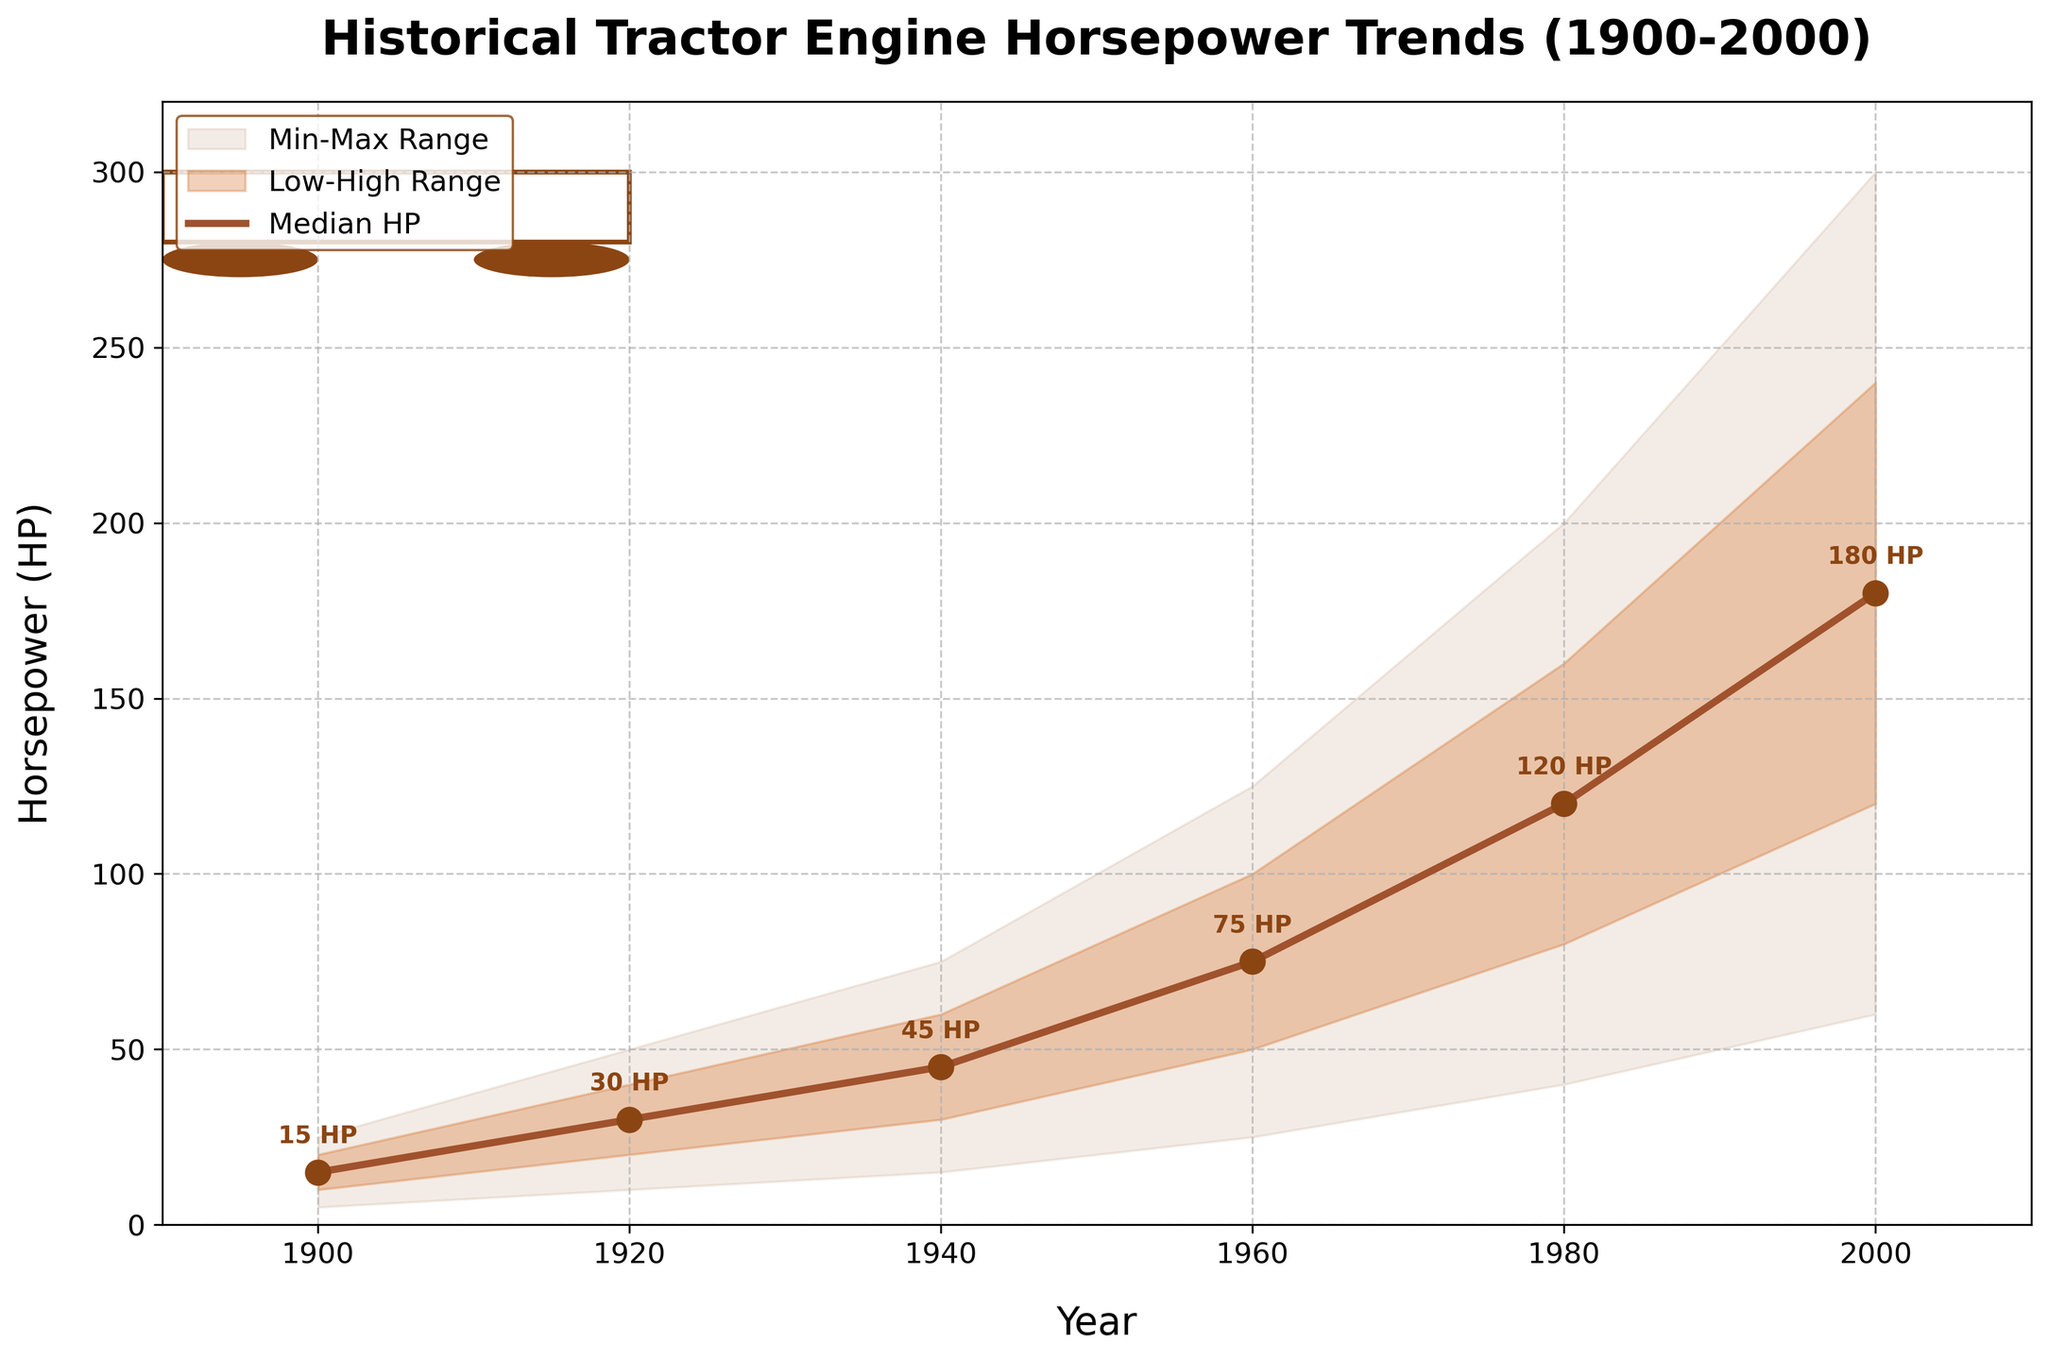What is the title of the figure? The title of the figure is typically found at the top and provides an overview of what the figure represents. In this case, the title reads "Historical Tractor Engine Horsepower Trends (1900-2000)."
Answer: Historical Tractor Engine Horsepower Trends (1900-2000) What are the units used on the y-axis? The y-axis represents the measure of tractor engine horsepower, as indicated by the "Horsepower (HP)" label on the vertical axis.
Answer: Horsepower (HP) How many years are displayed on the x-axis? To determine the number of years displayed, count each individual tick on the x-axis. The data represents the years 1900, 1920, 1940, 1960, 1980, and 2000.
Answer: 6 What is the range of horsepower in the year 2000? The range of horsepower for any given year can be found by looking at the Min HP and Max HP for that year. In the year 2000, Min HP is 60 and Max HP is 300.
Answer: 60 to 300 Which year shows the maximum median horsepower and what is the value? To find the maximum median horsepower, compare the median HP values across all years. The year 2000 shows the highest median HP value of 180.
Answer: 2000 (180 HP) What is the difference between the high and low horsepower in 1940? The high HP in 1940 is 60, and the low HP is 30. The difference is found by subtracting the low from the high: 60 - 30.
Answer: 30 How does the median horsepower in 1980 compare to that in 1960? To compare median horsepower for different years, look at the median HP values of each year. The median HP for 1980 is 120, and for 1960, it is 75. So, 1980's median is higher.
Answer: 1980 > 1960 What trends do you observe in the median horsepower from 1900 to 2000? Observing the median HP values over time shows a consistently increasing trend. Starting from 15 HP in 1900 and reaching 180 HP by 2000, median horsepower has risen steadily.
Answer: Increasing trend What is the median horsepower in 1920, and how does it compare to that in 1900? The median HP in 1920 is 30, while in 1900 it is 15. To compare, note that the 1920 median is twice as high as that of 1900.
Answer: 1920 is higher (30 vs 15) What does the shaded area between Min HP and Max HP represent? The shaded area between Min HP and Max HP in a fan chart represents the full range of horsepower values, illustrating the spread of data points from the minimum to the maximum value for each year.
Answer: Full range of horsepower values 